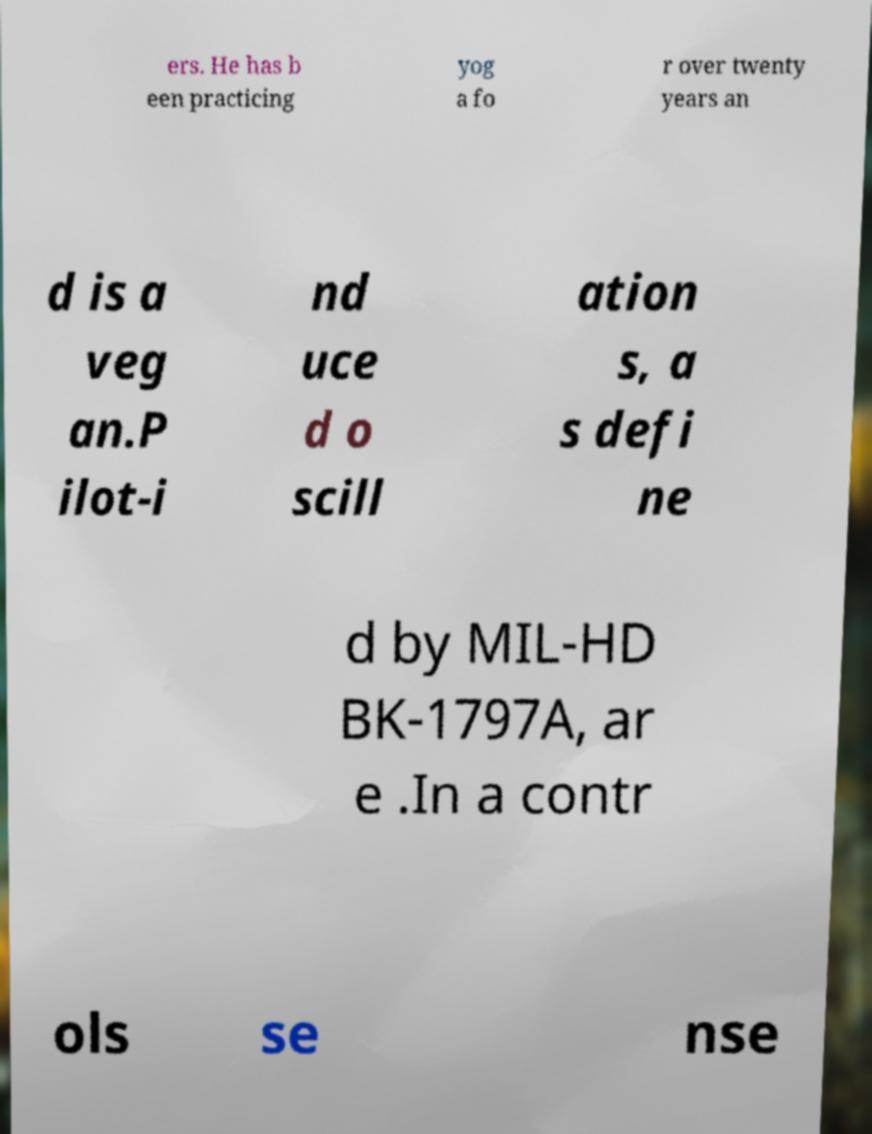Can you accurately transcribe the text from the provided image for me? ers. He has b een practicing yog a fo r over twenty years an d is a veg an.P ilot-i nd uce d o scill ation s, a s defi ne d by MIL-HD BK-1797A, ar e .In a contr ols se nse 